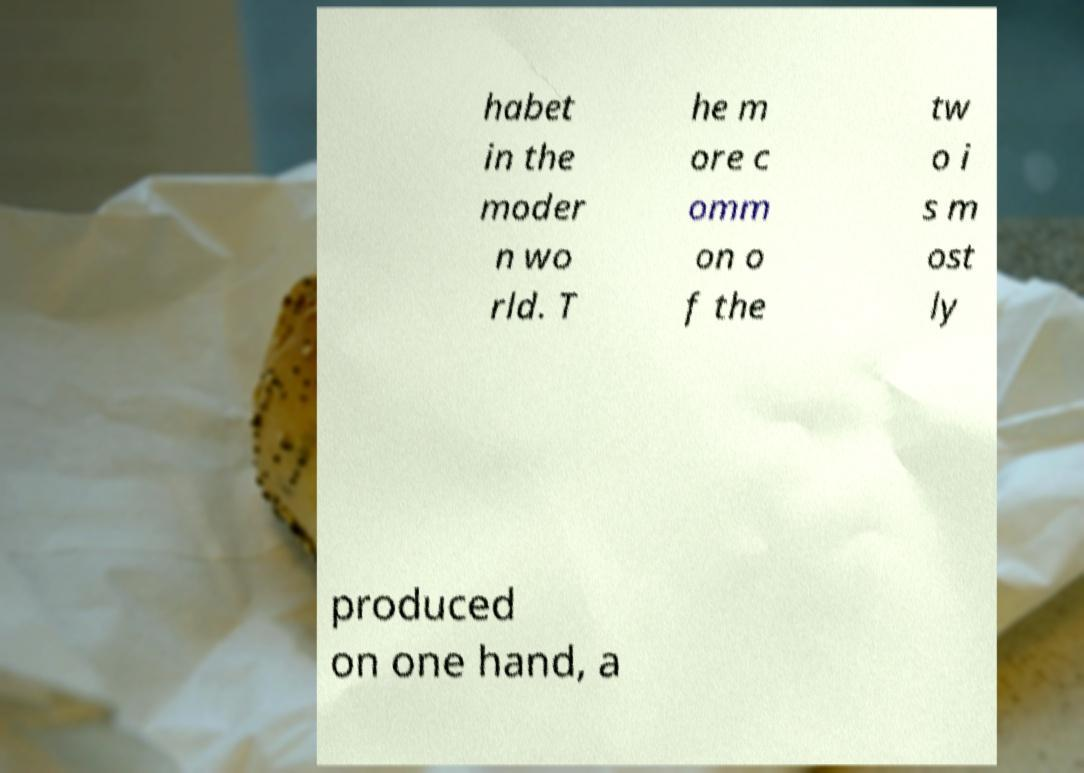Can you read and provide the text displayed in the image?This photo seems to have some interesting text. Can you extract and type it out for me? habet in the moder n wo rld. T he m ore c omm on o f the tw o i s m ost ly produced on one hand, a 